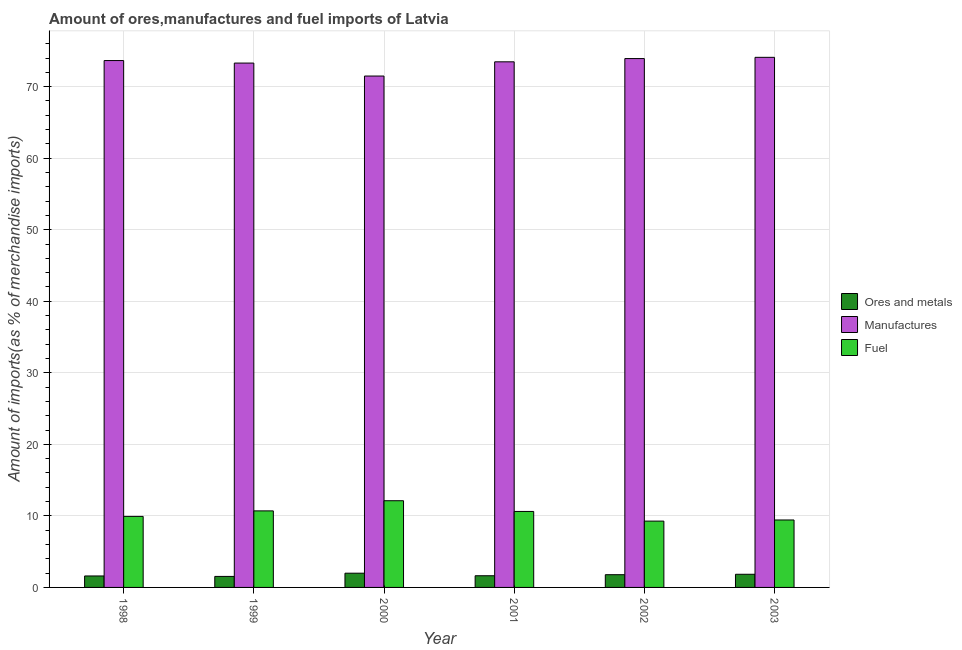How many groups of bars are there?
Ensure brevity in your answer.  6. Are the number of bars per tick equal to the number of legend labels?
Offer a very short reply. Yes. Are the number of bars on each tick of the X-axis equal?
Keep it short and to the point. Yes. How many bars are there on the 4th tick from the left?
Make the answer very short. 3. What is the label of the 4th group of bars from the left?
Your answer should be compact. 2001. In how many cases, is the number of bars for a given year not equal to the number of legend labels?
Your answer should be very brief. 0. What is the percentage of manufactures imports in 2003?
Offer a terse response. 74.1. Across all years, what is the maximum percentage of fuel imports?
Provide a short and direct response. 12.12. Across all years, what is the minimum percentage of ores and metals imports?
Ensure brevity in your answer.  1.54. In which year was the percentage of ores and metals imports minimum?
Provide a succinct answer. 1999. What is the total percentage of fuel imports in the graph?
Provide a succinct answer. 62.07. What is the difference between the percentage of fuel imports in 2000 and that in 2003?
Keep it short and to the point. 2.69. What is the difference between the percentage of fuel imports in 1999 and the percentage of manufactures imports in 2001?
Provide a short and direct response. 0.08. What is the average percentage of fuel imports per year?
Provide a succinct answer. 10.35. In how many years, is the percentage of fuel imports greater than 36 %?
Your answer should be very brief. 0. What is the ratio of the percentage of fuel imports in 2000 to that in 2003?
Ensure brevity in your answer.  1.29. Is the difference between the percentage of ores and metals imports in 2000 and 2003 greater than the difference between the percentage of manufactures imports in 2000 and 2003?
Your response must be concise. No. What is the difference between the highest and the second highest percentage of ores and metals imports?
Provide a short and direct response. 0.15. What is the difference between the highest and the lowest percentage of fuel imports?
Make the answer very short. 2.85. In how many years, is the percentage of manufactures imports greater than the average percentage of manufactures imports taken over all years?
Make the answer very short. 4. Is the sum of the percentage of fuel imports in 1998 and 2003 greater than the maximum percentage of manufactures imports across all years?
Ensure brevity in your answer.  Yes. What does the 1st bar from the left in 1998 represents?
Offer a very short reply. Ores and metals. What does the 1st bar from the right in 2001 represents?
Your response must be concise. Fuel. How many bars are there?
Give a very brief answer. 18. Are all the bars in the graph horizontal?
Offer a very short reply. No. How many years are there in the graph?
Your answer should be compact. 6. What is the difference between two consecutive major ticks on the Y-axis?
Your response must be concise. 10. Does the graph contain any zero values?
Provide a short and direct response. No. Where does the legend appear in the graph?
Offer a terse response. Center right. How are the legend labels stacked?
Make the answer very short. Vertical. What is the title of the graph?
Make the answer very short. Amount of ores,manufactures and fuel imports of Latvia. What is the label or title of the Y-axis?
Your answer should be very brief. Amount of imports(as % of merchandise imports). What is the Amount of imports(as % of merchandise imports) in Ores and metals in 1998?
Keep it short and to the point. 1.6. What is the Amount of imports(as % of merchandise imports) in Manufactures in 1998?
Your response must be concise. 73.65. What is the Amount of imports(as % of merchandise imports) of Fuel in 1998?
Provide a short and direct response. 9.93. What is the Amount of imports(as % of merchandise imports) in Ores and metals in 1999?
Make the answer very short. 1.54. What is the Amount of imports(as % of merchandise imports) in Manufactures in 1999?
Your response must be concise. 73.3. What is the Amount of imports(as % of merchandise imports) of Fuel in 1999?
Give a very brief answer. 10.7. What is the Amount of imports(as % of merchandise imports) of Ores and metals in 2000?
Your answer should be compact. 1.99. What is the Amount of imports(as % of merchandise imports) in Manufactures in 2000?
Provide a succinct answer. 71.49. What is the Amount of imports(as % of merchandise imports) of Fuel in 2000?
Make the answer very short. 12.12. What is the Amount of imports(as % of merchandise imports) of Ores and metals in 2001?
Keep it short and to the point. 1.63. What is the Amount of imports(as % of merchandise imports) of Manufactures in 2001?
Your response must be concise. 73.48. What is the Amount of imports(as % of merchandise imports) of Fuel in 2001?
Your answer should be compact. 10.62. What is the Amount of imports(as % of merchandise imports) of Ores and metals in 2002?
Offer a very short reply. 1.78. What is the Amount of imports(as % of merchandise imports) of Manufactures in 2002?
Your answer should be very brief. 73.93. What is the Amount of imports(as % of merchandise imports) of Fuel in 2002?
Provide a succinct answer. 9.27. What is the Amount of imports(as % of merchandise imports) of Ores and metals in 2003?
Your response must be concise. 1.84. What is the Amount of imports(as % of merchandise imports) in Manufactures in 2003?
Your response must be concise. 74.1. What is the Amount of imports(as % of merchandise imports) in Fuel in 2003?
Offer a very short reply. 9.43. Across all years, what is the maximum Amount of imports(as % of merchandise imports) in Ores and metals?
Offer a very short reply. 1.99. Across all years, what is the maximum Amount of imports(as % of merchandise imports) in Manufactures?
Make the answer very short. 74.1. Across all years, what is the maximum Amount of imports(as % of merchandise imports) of Fuel?
Offer a terse response. 12.12. Across all years, what is the minimum Amount of imports(as % of merchandise imports) in Ores and metals?
Your response must be concise. 1.54. Across all years, what is the minimum Amount of imports(as % of merchandise imports) of Manufactures?
Ensure brevity in your answer.  71.49. Across all years, what is the minimum Amount of imports(as % of merchandise imports) of Fuel?
Make the answer very short. 9.27. What is the total Amount of imports(as % of merchandise imports) of Ores and metals in the graph?
Provide a short and direct response. 10.38. What is the total Amount of imports(as % of merchandise imports) in Manufactures in the graph?
Provide a short and direct response. 439.96. What is the total Amount of imports(as % of merchandise imports) in Fuel in the graph?
Ensure brevity in your answer.  62.07. What is the difference between the Amount of imports(as % of merchandise imports) of Ores and metals in 1998 and that in 1999?
Your answer should be compact. 0.06. What is the difference between the Amount of imports(as % of merchandise imports) in Manufactures in 1998 and that in 1999?
Your response must be concise. 0.35. What is the difference between the Amount of imports(as % of merchandise imports) of Fuel in 1998 and that in 1999?
Your answer should be compact. -0.77. What is the difference between the Amount of imports(as % of merchandise imports) in Ores and metals in 1998 and that in 2000?
Your answer should be compact. -0.39. What is the difference between the Amount of imports(as % of merchandise imports) in Manufactures in 1998 and that in 2000?
Give a very brief answer. 2.16. What is the difference between the Amount of imports(as % of merchandise imports) in Fuel in 1998 and that in 2000?
Your response must be concise. -2.19. What is the difference between the Amount of imports(as % of merchandise imports) of Ores and metals in 1998 and that in 2001?
Make the answer very short. -0.03. What is the difference between the Amount of imports(as % of merchandise imports) of Manufactures in 1998 and that in 2001?
Your answer should be very brief. 0.18. What is the difference between the Amount of imports(as % of merchandise imports) of Fuel in 1998 and that in 2001?
Give a very brief answer. -0.69. What is the difference between the Amount of imports(as % of merchandise imports) in Ores and metals in 1998 and that in 2002?
Offer a terse response. -0.18. What is the difference between the Amount of imports(as % of merchandise imports) in Manufactures in 1998 and that in 2002?
Offer a very short reply. -0.28. What is the difference between the Amount of imports(as % of merchandise imports) in Fuel in 1998 and that in 2002?
Provide a succinct answer. 0.66. What is the difference between the Amount of imports(as % of merchandise imports) in Ores and metals in 1998 and that in 2003?
Offer a very short reply. -0.23. What is the difference between the Amount of imports(as % of merchandise imports) of Manufactures in 1998 and that in 2003?
Offer a terse response. -0.45. What is the difference between the Amount of imports(as % of merchandise imports) of Fuel in 1998 and that in 2003?
Your response must be concise. 0.5. What is the difference between the Amount of imports(as % of merchandise imports) in Ores and metals in 1999 and that in 2000?
Provide a succinct answer. -0.45. What is the difference between the Amount of imports(as % of merchandise imports) in Manufactures in 1999 and that in 2000?
Provide a short and direct response. 1.81. What is the difference between the Amount of imports(as % of merchandise imports) of Fuel in 1999 and that in 2000?
Provide a short and direct response. -1.42. What is the difference between the Amount of imports(as % of merchandise imports) in Ores and metals in 1999 and that in 2001?
Offer a very short reply. -0.09. What is the difference between the Amount of imports(as % of merchandise imports) in Manufactures in 1999 and that in 2001?
Provide a succinct answer. -0.17. What is the difference between the Amount of imports(as % of merchandise imports) of Fuel in 1999 and that in 2001?
Offer a terse response. 0.08. What is the difference between the Amount of imports(as % of merchandise imports) of Ores and metals in 1999 and that in 2002?
Ensure brevity in your answer.  -0.24. What is the difference between the Amount of imports(as % of merchandise imports) of Manufactures in 1999 and that in 2002?
Provide a succinct answer. -0.63. What is the difference between the Amount of imports(as % of merchandise imports) of Fuel in 1999 and that in 2002?
Provide a succinct answer. 1.43. What is the difference between the Amount of imports(as % of merchandise imports) in Ores and metals in 1999 and that in 2003?
Offer a terse response. -0.3. What is the difference between the Amount of imports(as % of merchandise imports) in Manufactures in 1999 and that in 2003?
Your answer should be very brief. -0.8. What is the difference between the Amount of imports(as % of merchandise imports) in Fuel in 1999 and that in 2003?
Give a very brief answer. 1.27. What is the difference between the Amount of imports(as % of merchandise imports) in Ores and metals in 2000 and that in 2001?
Offer a terse response. 0.36. What is the difference between the Amount of imports(as % of merchandise imports) of Manufactures in 2000 and that in 2001?
Offer a very short reply. -1.99. What is the difference between the Amount of imports(as % of merchandise imports) of Fuel in 2000 and that in 2001?
Provide a short and direct response. 1.5. What is the difference between the Amount of imports(as % of merchandise imports) of Ores and metals in 2000 and that in 2002?
Provide a succinct answer. 0.21. What is the difference between the Amount of imports(as % of merchandise imports) in Manufactures in 2000 and that in 2002?
Your answer should be compact. -2.44. What is the difference between the Amount of imports(as % of merchandise imports) of Fuel in 2000 and that in 2002?
Offer a very short reply. 2.85. What is the difference between the Amount of imports(as % of merchandise imports) of Ores and metals in 2000 and that in 2003?
Provide a succinct answer. 0.15. What is the difference between the Amount of imports(as % of merchandise imports) in Manufactures in 2000 and that in 2003?
Provide a succinct answer. -2.61. What is the difference between the Amount of imports(as % of merchandise imports) in Fuel in 2000 and that in 2003?
Give a very brief answer. 2.69. What is the difference between the Amount of imports(as % of merchandise imports) of Ores and metals in 2001 and that in 2002?
Offer a terse response. -0.15. What is the difference between the Amount of imports(as % of merchandise imports) in Manufactures in 2001 and that in 2002?
Keep it short and to the point. -0.46. What is the difference between the Amount of imports(as % of merchandise imports) in Fuel in 2001 and that in 2002?
Make the answer very short. 1.35. What is the difference between the Amount of imports(as % of merchandise imports) of Ores and metals in 2001 and that in 2003?
Offer a terse response. -0.2. What is the difference between the Amount of imports(as % of merchandise imports) of Manufactures in 2001 and that in 2003?
Your answer should be compact. -0.63. What is the difference between the Amount of imports(as % of merchandise imports) of Fuel in 2001 and that in 2003?
Keep it short and to the point. 1.19. What is the difference between the Amount of imports(as % of merchandise imports) in Ores and metals in 2002 and that in 2003?
Your response must be concise. -0.06. What is the difference between the Amount of imports(as % of merchandise imports) of Manufactures in 2002 and that in 2003?
Offer a very short reply. -0.17. What is the difference between the Amount of imports(as % of merchandise imports) of Fuel in 2002 and that in 2003?
Offer a terse response. -0.16. What is the difference between the Amount of imports(as % of merchandise imports) in Ores and metals in 1998 and the Amount of imports(as % of merchandise imports) in Manufactures in 1999?
Offer a terse response. -71.7. What is the difference between the Amount of imports(as % of merchandise imports) in Ores and metals in 1998 and the Amount of imports(as % of merchandise imports) in Fuel in 1999?
Offer a very short reply. -9.1. What is the difference between the Amount of imports(as % of merchandise imports) of Manufactures in 1998 and the Amount of imports(as % of merchandise imports) of Fuel in 1999?
Your response must be concise. 62.95. What is the difference between the Amount of imports(as % of merchandise imports) in Ores and metals in 1998 and the Amount of imports(as % of merchandise imports) in Manufactures in 2000?
Give a very brief answer. -69.89. What is the difference between the Amount of imports(as % of merchandise imports) of Ores and metals in 1998 and the Amount of imports(as % of merchandise imports) of Fuel in 2000?
Your response must be concise. -10.52. What is the difference between the Amount of imports(as % of merchandise imports) in Manufactures in 1998 and the Amount of imports(as % of merchandise imports) in Fuel in 2000?
Offer a terse response. 61.53. What is the difference between the Amount of imports(as % of merchandise imports) of Ores and metals in 1998 and the Amount of imports(as % of merchandise imports) of Manufactures in 2001?
Your response must be concise. -71.87. What is the difference between the Amount of imports(as % of merchandise imports) in Ores and metals in 1998 and the Amount of imports(as % of merchandise imports) in Fuel in 2001?
Offer a terse response. -9.02. What is the difference between the Amount of imports(as % of merchandise imports) of Manufactures in 1998 and the Amount of imports(as % of merchandise imports) of Fuel in 2001?
Offer a terse response. 63.03. What is the difference between the Amount of imports(as % of merchandise imports) in Ores and metals in 1998 and the Amount of imports(as % of merchandise imports) in Manufactures in 2002?
Make the answer very short. -72.33. What is the difference between the Amount of imports(as % of merchandise imports) in Ores and metals in 1998 and the Amount of imports(as % of merchandise imports) in Fuel in 2002?
Make the answer very short. -7.67. What is the difference between the Amount of imports(as % of merchandise imports) in Manufactures in 1998 and the Amount of imports(as % of merchandise imports) in Fuel in 2002?
Your answer should be compact. 64.38. What is the difference between the Amount of imports(as % of merchandise imports) of Ores and metals in 1998 and the Amount of imports(as % of merchandise imports) of Manufactures in 2003?
Your answer should be compact. -72.5. What is the difference between the Amount of imports(as % of merchandise imports) in Ores and metals in 1998 and the Amount of imports(as % of merchandise imports) in Fuel in 2003?
Keep it short and to the point. -7.83. What is the difference between the Amount of imports(as % of merchandise imports) of Manufactures in 1998 and the Amount of imports(as % of merchandise imports) of Fuel in 2003?
Your answer should be very brief. 64.22. What is the difference between the Amount of imports(as % of merchandise imports) of Ores and metals in 1999 and the Amount of imports(as % of merchandise imports) of Manufactures in 2000?
Keep it short and to the point. -69.95. What is the difference between the Amount of imports(as % of merchandise imports) in Ores and metals in 1999 and the Amount of imports(as % of merchandise imports) in Fuel in 2000?
Provide a short and direct response. -10.58. What is the difference between the Amount of imports(as % of merchandise imports) in Manufactures in 1999 and the Amount of imports(as % of merchandise imports) in Fuel in 2000?
Offer a very short reply. 61.18. What is the difference between the Amount of imports(as % of merchandise imports) in Ores and metals in 1999 and the Amount of imports(as % of merchandise imports) in Manufactures in 2001?
Your response must be concise. -71.94. What is the difference between the Amount of imports(as % of merchandise imports) of Ores and metals in 1999 and the Amount of imports(as % of merchandise imports) of Fuel in 2001?
Your response must be concise. -9.08. What is the difference between the Amount of imports(as % of merchandise imports) of Manufactures in 1999 and the Amount of imports(as % of merchandise imports) of Fuel in 2001?
Ensure brevity in your answer.  62.68. What is the difference between the Amount of imports(as % of merchandise imports) in Ores and metals in 1999 and the Amount of imports(as % of merchandise imports) in Manufactures in 2002?
Give a very brief answer. -72.39. What is the difference between the Amount of imports(as % of merchandise imports) of Ores and metals in 1999 and the Amount of imports(as % of merchandise imports) of Fuel in 2002?
Keep it short and to the point. -7.73. What is the difference between the Amount of imports(as % of merchandise imports) of Manufactures in 1999 and the Amount of imports(as % of merchandise imports) of Fuel in 2002?
Your answer should be very brief. 64.03. What is the difference between the Amount of imports(as % of merchandise imports) in Ores and metals in 1999 and the Amount of imports(as % of merchandise imports) in Manufactures in 2003?
Ensure brevity in your answer.  -72.56. What is the difference between the Amount of imports(as % of merchandise imports) in Ores and metals in 1999 and the Amount of imports(as % of merchandise imports) in Fuel in 2003?
Provide a succinct answer. -7.89. What is the difference between the Amount of imports(as % of merchandise imports) in Manufactures in 1999 and the Amount of imports(as % of merchandise imports) in Fuel in 2003?
Your answer should be compact. 63.87. What is the difference between the Amount of imports(as % of merchandise imports) of Ores and metals in 2000 and the Amount of imports(as % of merchandise imports) of Manufactures in 2001?
Your answer should be compact. -71.49. What is the difference between the Amount of imports(as % of merchandise imports) in Ores and metals in 2000 and the Amount of imports(as % of merchandise imports) in Fuel in 2001?
Your answer should be very brief. -8.63. What is the difference between the Amount of imports(as % of merchandise imports) in Manufactures in 2000 and the Amount of imports(as % of merchandise imports) in Fuel in 2001?
Offer a very short reply. 60.87. What is the difference between the Amount of imports(as % of merchandise imports) of Ores and metals in 2000 and the Amount of imports(as % of merchandise imports) of Manufactures in 2002?
Provide a succinct answer. -71.94. What is the difference between the Amount of imports(as % of merchandise imports) in Ores and metals in 2000 and the Amount of imports(as % of merchandise imports) in Fuel in 2002?
Make the answer very short. -7.28. What is the difference between the Amount of imports(as % of merchandise imports) in Manufactures in 2000 and the Amount of imports(as % of merchandise imports) in Fuel in 2002?
Give a very brief answer. 62.22. What is the difference between the Amount of imports(as % of merchandise imports) of Ores and metals in 2000 and the Amount of imports(as % of merchandise imports) of Manufactures in 2003?
Provide a short and direct response. -72.11. What is the difference between the Amount of imports(as % of merchandise imports) in Ores and metals in 2000 and the Amount of imports(as % of merchandise imports) in Fuel in 2003?
Make the answer very short. -7.44. What is the difference between the Amount of imports(as % of merchandise imports) of Manufactures in 2000 and the Amount of imports(as % of merchandise imports) of Fuel in 2003?
Your answer should be compact. 62.06. What is the difference between the Amount of imports(as % of merchandise imports) in Ores and metals in 2001 and the Amount of imports(as % of merchandise imports) in Manufactures in 2002?
Provide a succinct answer. -72.3. What is the difference between the Amount of imports(as % of merchandise imports) of Ores and metals in 2001 and the Amount of imports(as % of merchandise imports) of Fuel in 2002?
Your answer should be compact. -7.64. What is the difference between the Amount of imports(as % of merchandise imports) of Manufactures in 2001 and the Amount of imports(as % of merchandise imports) of Fuel in 2002?
Provide a succinct answer. 64.2. What is the difference between the Amount of imports(as % of merchandise imports) in Ores and metals in 2001 and the Amount of imports(as % of merchandise imports) in Manufactures in 2003?
Provide a succinct answer. -72.47. What is the difference between the Amount of imports(as % of merchandise imports) in Ores and metals in 2001 and the Amount of imports(as % of merchandise imports) in Fuel in 2003?
Make the answer very short. -7.8. What is the difference between the Amount of imports(as % of merchandise imports) in Manufactures in 2001 and the Amount of imports(as % of merchandise imports) in Fuel in 2003?
Ensure brevity in your answer.  64.05. What is the difference between the Amount of imports(as % of merchandise imports) of Ores and metals in 2002 and the Amount of imports(as % of merchandise imports) of Manufactures in 2003?
Offer a terse response. -72.32. What is the difference between the Amount of imports(as % of merchandise imports) in Ores and metals in 2002 and the Amount of imports(as % of merchandise imports) in Fuel in 2003?
Provide a short and direct response. -7.65. What is the difference between the Amount of imports(as % of merchandise imports) of Manufactures in 2002 and the Amount of imports(as % of merchandise imports) of Fuel in 2003?
Your answer should be compact. 64.5. What is the average Amount of imports(as % of merchandise imports) of Ores and metals per year?
Keep it short and to the point. 1.73. What is the average Amount of imports(as % of merchandise imports) of Manufactures per year?
Provide a short and direct response. 73.33. What is the average Amount of imports(as % of merchandise imports) of Fuel per year?
Your answer should be compact. 10.35. In the year 1998, what is the difference between the Amount of imports(as % of merchandise imports) of Ores and metals and Amount of imports(as % of merchandise imports) of Manufactures?
Keep it short and to the point. -72.05. In the year 1998, what is the difference between the Amount of imports(as % of merchandise imports) in Ores and metals and Amount of imports(as % of merchandise imports) in Fuel?
Your response must be concise. -8.33. In the year 1998, what is the difference between the Amount of imports(as % of merchandise imports) of Manufactures and Amount of imports(as % of merchandise imports) of Fuel?
Your answer should be compact. 63.72. In the year 1999, what is the difference between the Amount of imports(as % of merchandise imports) in Ores and metals and Amount of imports(as % of merchandise imports) in Manufactures?
Offer a very short reply. -71.76. In the year 1999, what is the difference between the Amount of imports(as % of merchandise imports) in Ores and metals and Amount of imports(as % of merchandise imports) in Fuel?
Keep it short and to the point. -9.16. In the year 1999, what is the difference between the Amount of imports(as % of merchandise imports) in Manufactures and Amount of imports(as % of merchandise imports) in Fuel?
Give a very brief answer. 62.6. In the year 2000, what is the difference between the Amount of imports(as % of merchandise imports) of Ores and metals and Amount of imports(as % of merchandise imports) of Manufactures?
Give a very brief answer. -69.5. In the year 2000, what is the difference between the Amount of imports(as % of merchandise imports) of Ores and metals and Amount of imports(as % of merchandise imports) of Fuel?
Offer a very short reply. -10.13. In the year 2000, what is the difference between the Amount of imports(as % of merchandise imports) in Manufactures and Amount of imports(as % of merchandise imports) in Fuel?
Your answer should be very brief. 59.37. In the year 2001, what is the difference between the Amount of imports(as % of merchandise imports) of Ores and metals and Amount of imports(as % of merchandise imports) of Manufactures?
Give a very brief answer. -71.84. In the year 2001, what is the difference between the Amount of imports(as % of merchandise imports) in Ores and metals and Amount of imports(as % of merchandise imports) in Fuel?
Your response must be concise. -8.99. In the year 2001, what is the difference between the Amount of imports(as % of merchandise imports) in Manufactures and Amount of imports(as % of merchandise imports) in Fuel?
Keep it short and to the point. 62.85. In the year 2002, what is the difference between the Amount of imports(as % of merchandise imports) in Ores and metals and Amount of imports(as % of merchandise imports) in Manufactures?
Offer a terse response. -72.15. In the year 2002, what is the difference between the Amount of imports(as % of merchandise imports) of Ores and metals and Amount of imports(as % of merchandise imports) of Fuel?
Provide a short and direct response. -7.49. In the year 2002, what is the difference between the Amount of imports(as % of merchandise imports) of Manufactures and Amount of imports(as % of merchandise imports) of Fuel?
Offer a terse response. 64.66. In the year 2003, what is the difference between the Amount of imports(as % of merchandise imports) of Ores and metals and Amount of imports(as % of merchandise imports) of Manufactures?
Ensure brevity in your answer.  -72.27. In the year 2003, what is the difference between the Amount of imports(as % of merchandise imports) of Ores and metals and Amount of imports(as % of merchandise imports) of Fuel?
Your answer should be very brief. -7.59. In the year 2003, what is the difference between the Amount of imports(as % of merchandise imports) in Manufactures and Amount of imports(as % of merchandise imports) in Fuel?
Provide a short and direct response. 64.67. What is the ratio of the Amount of imports(as % of merchandise imports) of Ores and metals in 1998 to that in 1999?
Make the answer very short. 1.04. What is the ratio of the Amount of imports(as % of merchandise imports) of Manufactures in 1998 to that in 1999?
Provide a short and direct response. 1. What is the ratio of the Amount of imports(as % of merchandise imports) of Fuel in 1998 to that in 1999?
Provide a short and direct response. 0.93. What is the ratio of the Amount of imports(as % of merchandise imports) in Ores and metals in 1998 to that in 2000?
Your answer should be very brief. 0.81. What is the ratio of the Amount of imports(as % of merchandise imports) in Manufactures in 1998 to that in 2000?
Provide a succinct answer. 1.03. What is the ratio of the Amount of imports(as % of merchandise imports) in Fuel in 1998 to that in 2000?
Your response must be concise. 0.82. What is the ratio of the Amount of imports(as % of merchandise imports) in Ores and metals in 1998 to that in 2001?
Your answer should be very brief. 0.98. What is the ratio of the Amount of imports(as % of merchandise imports) in Fuel in 1998 to that in 2001?
Provide a short and direct response. 0.93. What is the ratio of the Amount of imports(as % of merchandise imports) in Ores and metals in 1998 to that in 2002?
Offer a terse response. 0.9. What is the ratio of the Amount of imports(as % of merchandise imports) of Manufactures in 1998 to that in 2002?
Give a very brief answer. 1. What is the ratio of the Amount of imports(as % of merchandise imports) in Fuel in 1998 to that in 2002?
Provide a succinct answer. 1.07. What is the ratio of the Amount of imports(as % of merchandise imports) of Ores and metals in 1998 to that in 2003?
Your answer should be very brief. 0.87. What is the ratio of the Amount of imports(as % of merchandise imports) of Fuel in 1998 to that in 2003?
Provide a succinct answer. 1.05. What is the ratio of the Amount of imports(as % of merchandise imports) in Ores and metals in 1999 to that in 2000?
Your answer should be compact. 0.77. What is the ratio of the Amount of imports(as % of merchandise imports) in Manufactures in 1999 to that in 2000?
Give a very brief answer. 1.03. What is the ratio of the Amount of imports(as % of merchandise imports) of Fuel in 1999 to that in 2000?
Make the answer very short. 0.88. What is the ratio of the Amount of imports(as % of merchandise imports) in Ores and metals in 1999 to that in 2001?
Offer a terse response. 0.94. What is the ratio of the Amount of imports(as % of merchandise imports) in Fuel in 1999 to that in 2001?
Keep it short and to the point. 1.01. What is the ratio of the Amount of imports(as % of merchandise imports) in Ores and metals in 1999 to that in 2002?
Provide a succinct answer. 0.86. What is the ratio of the Amount of imports(as % of merchandise imports) in Fuel in 1999 to that in 2002?
Your answer should be very brief. 1.15. What is the ratio of the Amount of imports(as % of merchandise imports) of Ores and metals in 1999 to that in 2003?
Offer a terse response. 0.84. What is the ratio of the Amount of imports(as % of merchandise imports) of Manufactures in 1999 to that in 2003?
Offer a terse response. 0.99. What is the ratio of the Amount of imports(as % of merchandise imports) in Fuel in 1999 to that in 2003?
Keep it short and to the point. 1.13. What is the ratio of the Amount of imports(as % of merchandise imports) of Ores and metals in 2000 to that in 2001?
Make the answer very short. 1.22. What is the ratio of the Amount of imports(as % of merchandise imports) of Fuel in 2000 to that in 2001?
Provide a succinct answer. 1.14. What is the ratio of the Amount of imports(as % of merchandise imports) in Ores and metals in 2000 to that in 2002?
Your response must be concise. 1.12. What is the ratio of the Amount of imports(as % of merchandise imports) of Manufactures in 2000 to that in 2002?
Your answer should be very brief. 0.97. What is the ratio of the Amount of imports(as % of merchandise imports) of Fuel in 2000 to that in 2002?
Offer a terse response. 1.31. What is the ratio of the Amount of imports(as % of merchandise imports) of Ores and metals in 2000 to that in 2003?
Ensure brevity in your answer.  1.08. What is the ratio of the Amount of imports(as % of merchandise imports) in Manufactures in 2000 to that in 2003?
Offer a very short reply. 0.96. What is the ratio of the Amount of imports(as % of merchandise imports) in Fuel in 2000 to that in 2003?
Provide a succinct answer. 1.29. What is the ratio of the Amount of imports(as % of merchandise imports) in Ores and metals in 2001 to that in 2002?
Provide a short and direct response. 0.92. What is the ratio of the Amount of imports(as % of merchandise imports) of Manufactures in 2001 to that in 2002?
Make the answer very short. 0.99. What is the ratio of the Amount of imports(as % of merchandise imports) in Fuel in 2001 to that in 2002?
Make the answer very short. 1.15. What is the ratio of the Amount of imports(as % of merchandise imports) in Ores and metals in 2001 to that in 2003?
Provide a succinct answer. 0.89. What is the ratio of the Amount of imports(as % of merchandise imports) of Fuel in 2001 to that in 2003?
Give a very brief answer. 1.13. What is the ratio of the Amount of imports(as % of merchandise imports) of Ores and metals in 2002 to that in 2003?
Provide a succinct answer. 0.97. What is the ratio of the Amount of imports(as % of merchandise imports) in Fuel in 2002 to that in 2003?
Provide a short and direct response. 0.98. What is the difference between the highest and the second highest Amount of imports(as % of merchandise imports) in Ores and metals?
Offer a terse response. 0.15. What is the difference between the highest and the second highest Amount of imports(as % of merchandise imports) in Manufactures?
Your answer should be compact. 0.17. What is the difference between the highest and the second highest Amount of imports(as % of merchandise imports) in Fuel?
Ensure brevity in your answer.  1.42. What is the difference between the highest and the lowest Amount of imports(as % of merchandise imports) of Ores and metals?
Provide a short and direct response. 0.45. What is the difference between the highest and the lowest Amount of imports(as % of merchandise imports) in Manufactures?
Your answer should be very brief. 2.61. What is the difference between the highest and the lowest Amount of imports(as % of merchandise imports) in Fuel?
Ensure brevity in your answer.  2.85. 